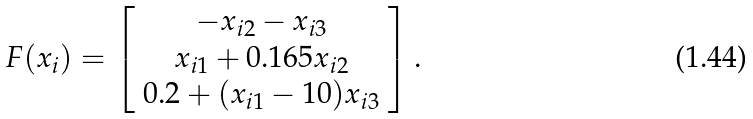<formula> <loc_0><loc_0><loc_500><loc_500>F ( x _ { i } ) = \left [ \begin{array} { c } - x _ { i 2 } - x _ { i 3 } \\ x _ { i 1 } + 0 . 1 6 5 x _ { i 2 } \\ 0 . 2 + ( x _ { i 1 } - 1 0 ) x _ { i 3 } \end{array} \right ] .</formula> 